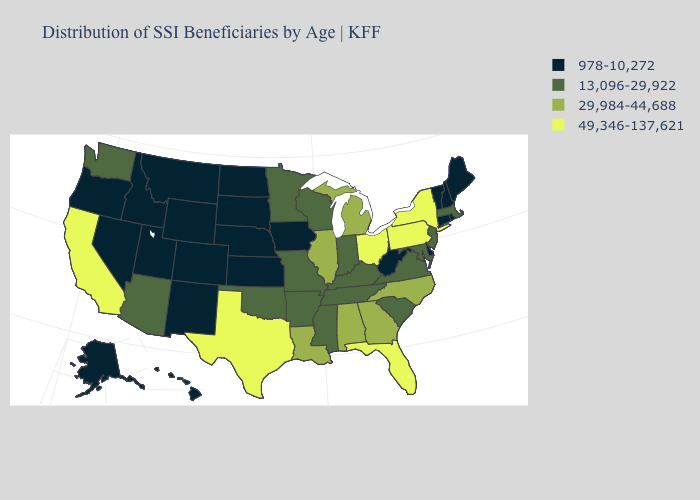Name the states that have a value in the range 13,096-29,922?
Concise answer only. Arizona, Arkansas, Indiana, Kentucky, Maryland, Massachusetts, Minnesota, Mississippi, Missouri, New Jersey, Oklahoma, South Carolina, Tennessee, Virginia, Washington, Wisconsin. What is the value of Delaware?
Concise answer only. 978-10,272. What is the lowest value in the South?
Give a very brief answer. 978-10,272. What is the value of Maine?
Write a very short answer. 978-10,272. What is the value of Arkansas?
Quick response, please. 13,096-29,922. What is the value of Tennessee?
Write a very short answer. 13,096-29,922. Does Wyoming have the lowest value in the West?
Write a very short answer. Yes. Does Kentucky have the same value as Mississippi?
Answer briefly. Yes. Does Minnesota have a lower value than Pennsylvania?
Give a very brief answer. Yes. Name the states that have a value in the range 978-10,272?
Give a very brief answer. Alaska, Colorado, Connecticut, Delaware, Hawaii, Idaho, Iowa, Kansas, Maine, Montana, Nebraska, Nevada, New Hampshire, New Mexico, North Dakota, Oregon, Rhode Island, South Dakota, Utah, Vermont, West Virginia, Wyoming. Which states have the highest value in the USA?
Write a very short answer. California, Florida, New York, Ohio, Pennsylvania, Texas. What is the value of Alaska?
Give a very brief answer. 978-10,272. What is the value of Connecticut?
Short answer required. 978-10,272. What is the lowest value in the USA?
Answer briefly. 978-10,272. Among the states that border Nevada , which have the highest value?
Give a very brief answer. California. 